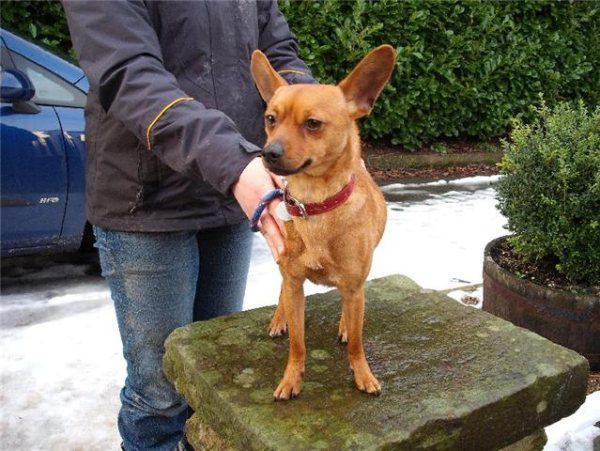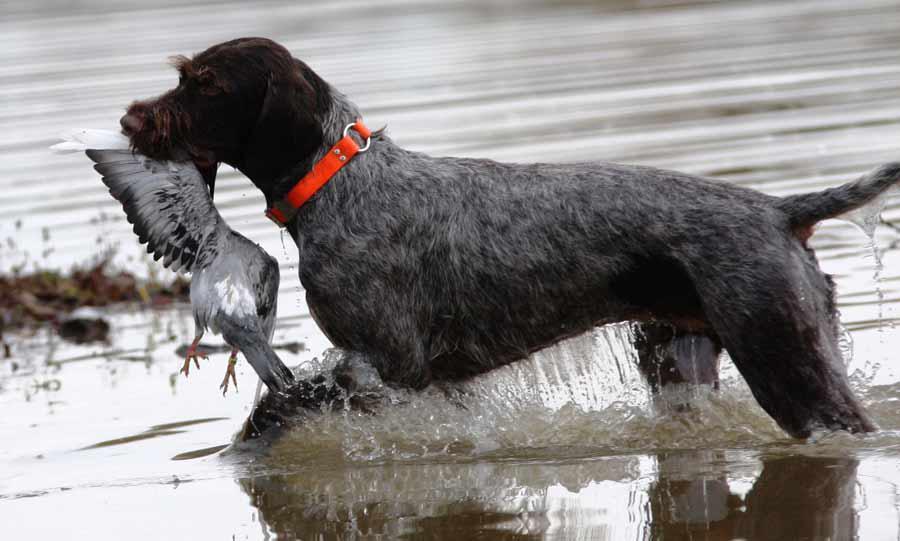The first image is the image on the left, the second image is the image on the right. Examine the images to the left and right. Is the description "There are exactly two live dogs." accurate? Answer yes or no. Yes. The first image is the image on the left, the second image is the image on the right. Considering the images on both sides, is "One image shows a single dog, which has short reddish-orange fur and is standing on an elevated platform with its body turned forward." valid? Answer yes or no. Yes. 